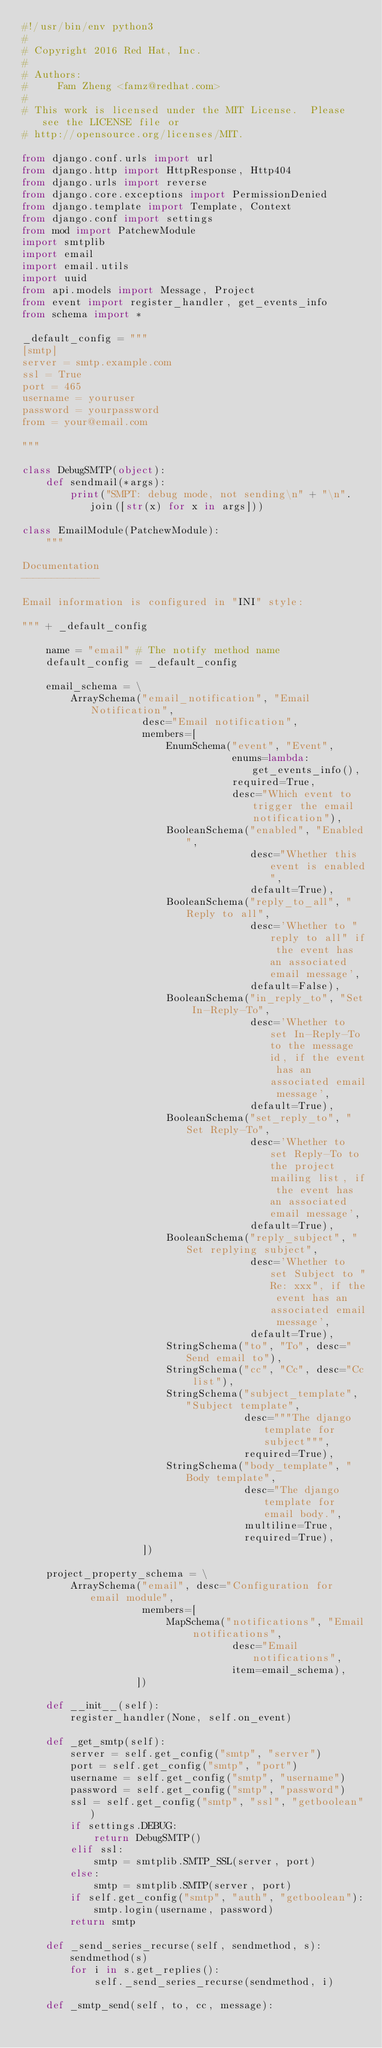<code> <loc_0><loc_0><loc_500><loc_500><_Python_>#!/usr/bin/env python3
#
# Copyright 2016 Red Hat, Inc.
#
# Authors:
#     Fam Zheng <famz@redhat.com>
#
# This work is licensed under the MIT License.  Please see the LICENSE file or
# http://opensource.org/licenses/MIT.

from django.conf.urls import url
from django.http import HttpResponse, Http404
from django.urls import reverse
from django.core.exceptions import PermissionDenied
from django.template import Template, Context
from django.conf import settings
from mod import PatchewModule
import smtplib
import email
import email.utils
import uuid
from api.models import Message, Project
from event import register_handler, get_events_info
from schema import *

_default_config = """
[smtp]
server = smtp.example.com
ssl = True
port = 465
username = youruser
password = yourpassword
from = your@email.com

"""

class DebugSMTP(object):
    def sendmail(*args):
        print("SMPT: debug mode, not sending\n" + "\n".join([str(x) for x in args]))

class EmailModule(PatchewModule):
    """

Documentation
-------------

Email information is configured in "INI" style:

""" + _default_config

    name = "email" # The notify method name
    default_config = _default_config

    email_schema = \
        ArraySchema("email_notification", "Email Notification",
                    desc="Email notification",
                    members=[
                        EnumSchema("event", "Event",
                                   enums=lambda: get_events_info(),
                                   required=True,
                                   desc="Which event to trigger the email notification"),
                        BooleanSchema("enabled", "Enabled",
                                      desc="Whether this event is enabled",
                                      default=True),
                        BooleanSchema("reply_to_all", "Reply to all",
                                      desc='Whether to "reply to all" if the event has an associated email message',
                                      default=False),
                        BooleanSchema("in_reply_to", "Set In-Reply-To",
                                      desc='Whether to set In-Reply-To to the message id, if the event has an associated email message',
                                      default=True),
                        BooleanSchema("set_reply_to", "Set Reply-To",
                                      desc='Whether to set Reply-To to the project mailing list, if the event has an associated email message',
                                      default=True),
                        BooleanSchema("reply_subject", "Set replying subject",
                                      desc='Whether to set Subject to "Re: xxx", if the event has an associated email message',
                                      default=True),
                        StringSchema("to", "To", desc="Send email to"),
                        StringSchema("cc", "Cc", desc="Cc list"),
                        StringSchema("subject_template", "Subject template",
                                     desc="""The django template for subject""",
                                     required=True),
                        StringSchema("body_template", "Body template",
                                     desc="The django template for email body.",
                                     multiline=True,
                                     required=True),
                    ])

    project_property_schema = \
        ArraySchema("email", desc="Configuration for email module",
                    members=[
                        MapSchema("notifications", "Email notifications",
                                   desc="Email notifications",
                                   item=email_schema),
                   ])

    def __init__(self):
        register_handler(None, self.on_event)

    def _get_smtp(self):
        server = self.get_config("smtp", "server")
        port = self.get_config("smtp", "port")
        username = self.get_config("smtp", "username")
        password = self.get_config("smtp", "password")
        ssl = self.get_config("smtp", "ssl", "getboolean")
        if settings.DEBUG:
            return DebugSMTP()
        elif ssl:
            smtp = smtplib.SMTP_SSL(server, port)
        else:
            smtp = smtplib.SMTP(server, port)
        if self.get_config("smtp", "auth", "getboolean"):
            smtp.login(username, password)
        return smtp

    def _send_series_recurse(self, sendmethod, s):
        sendmethod(s)
        for i in s.get_replies():
            self._send_series_recurse(sendmethod, i)

    def _smtp_send(self, to, cc, message):</code> 